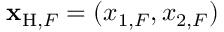Convert formula to latex. <formula><loc_0><loc_0><loc_500><loc_500>{ x } _ { H , F } = ( x _ { 1 , F } , x _ { 2 , F } )</formula> 